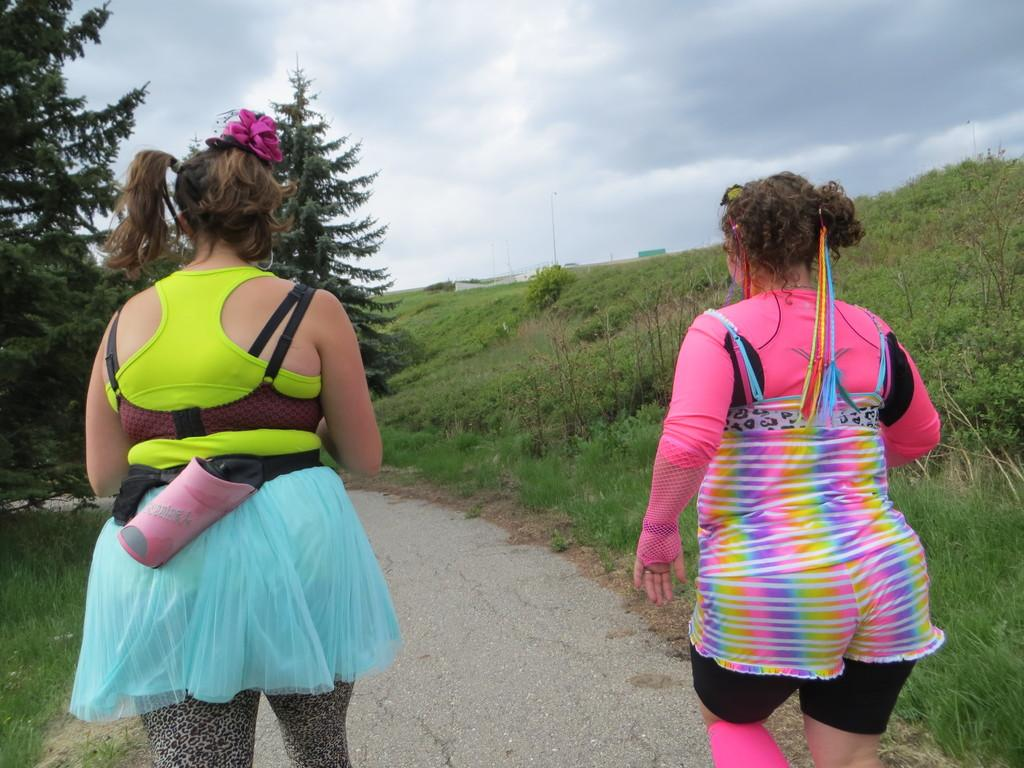How many people are in the image? There are two persons in the image. What can be seen in the image besides the people? There is a pathway, trees, plants, and the sky visible in the image. Can you describe the natural elements in the image? There are trees and plants in the image, which suggest a natural setting. What is visible in the background of the image? The sky is visible in the background of the image. What type of brick is being used to build the pathway in the image? There is no pathway made of bricks in the image; it is a pathway made of other materials. 